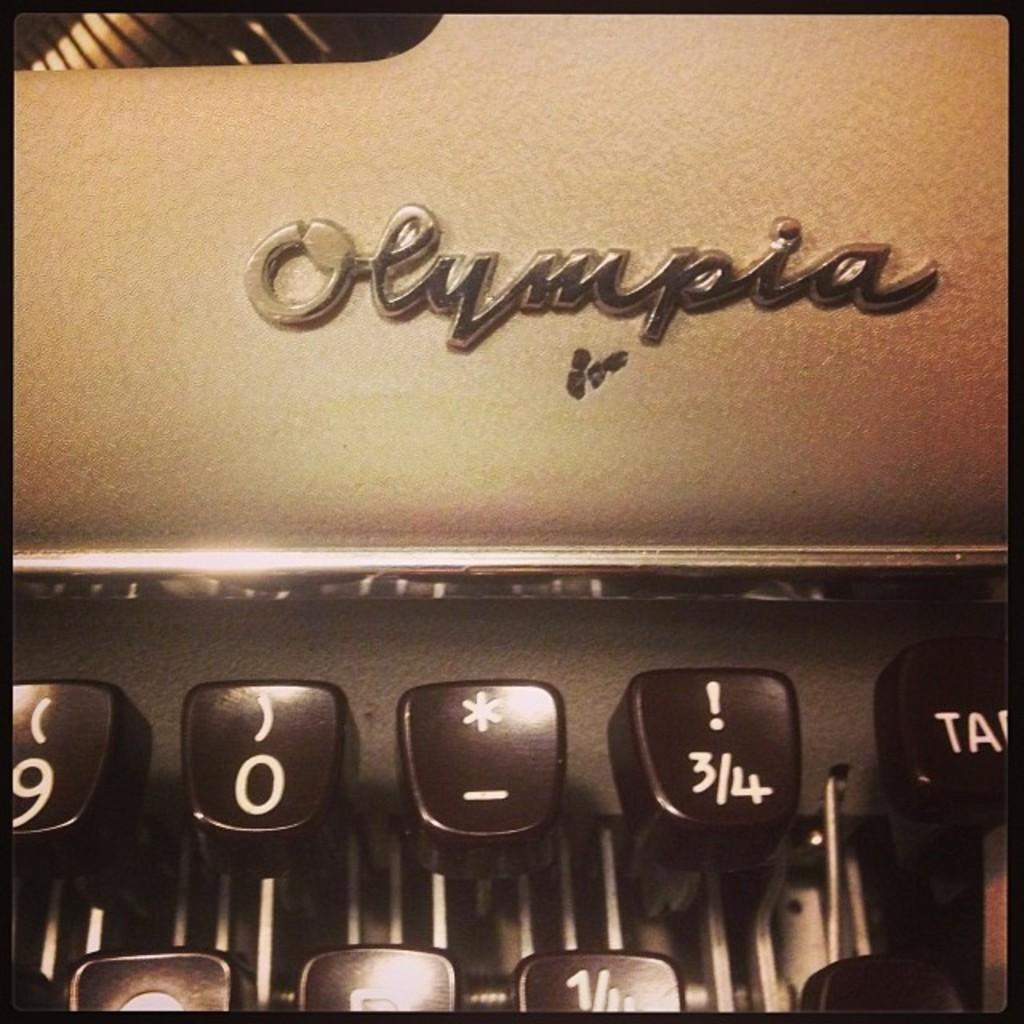<image>
Write a terse but informative summary of the picture. A small portion of an old Olympia typewriter. 